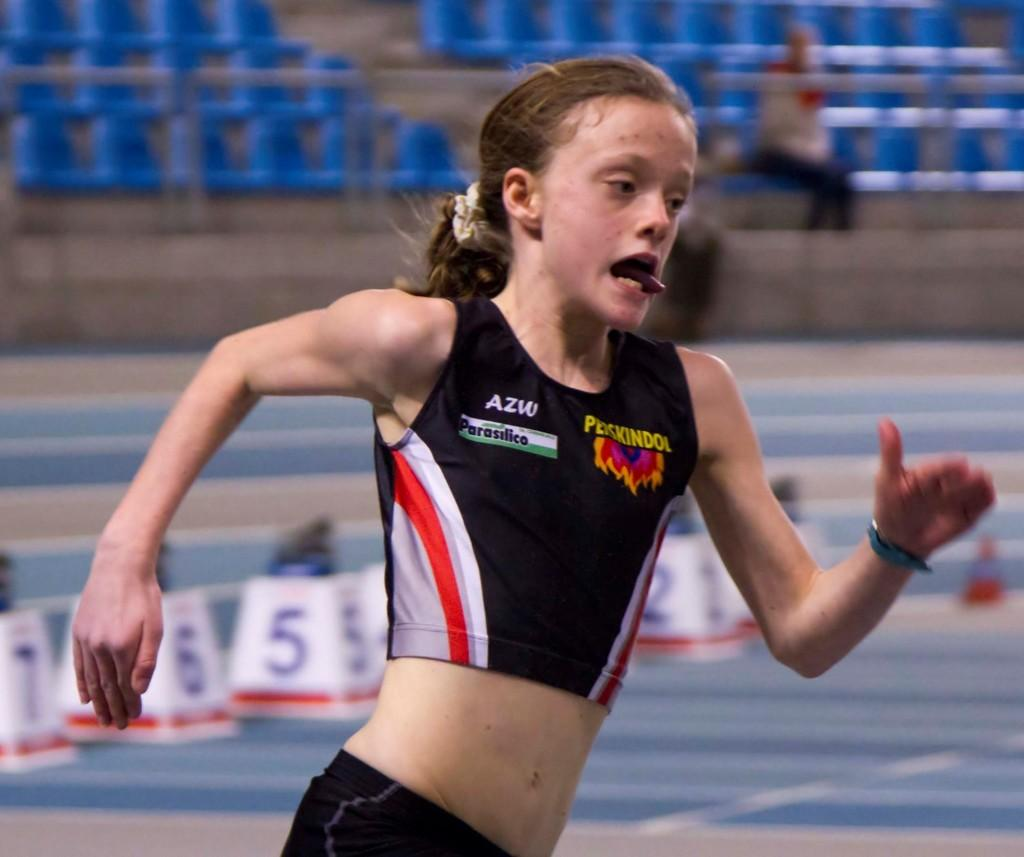<image>
Give a short and clear explanation of the subsequent image. A runner with her tongue out wears the letters AZW on her right chest. 